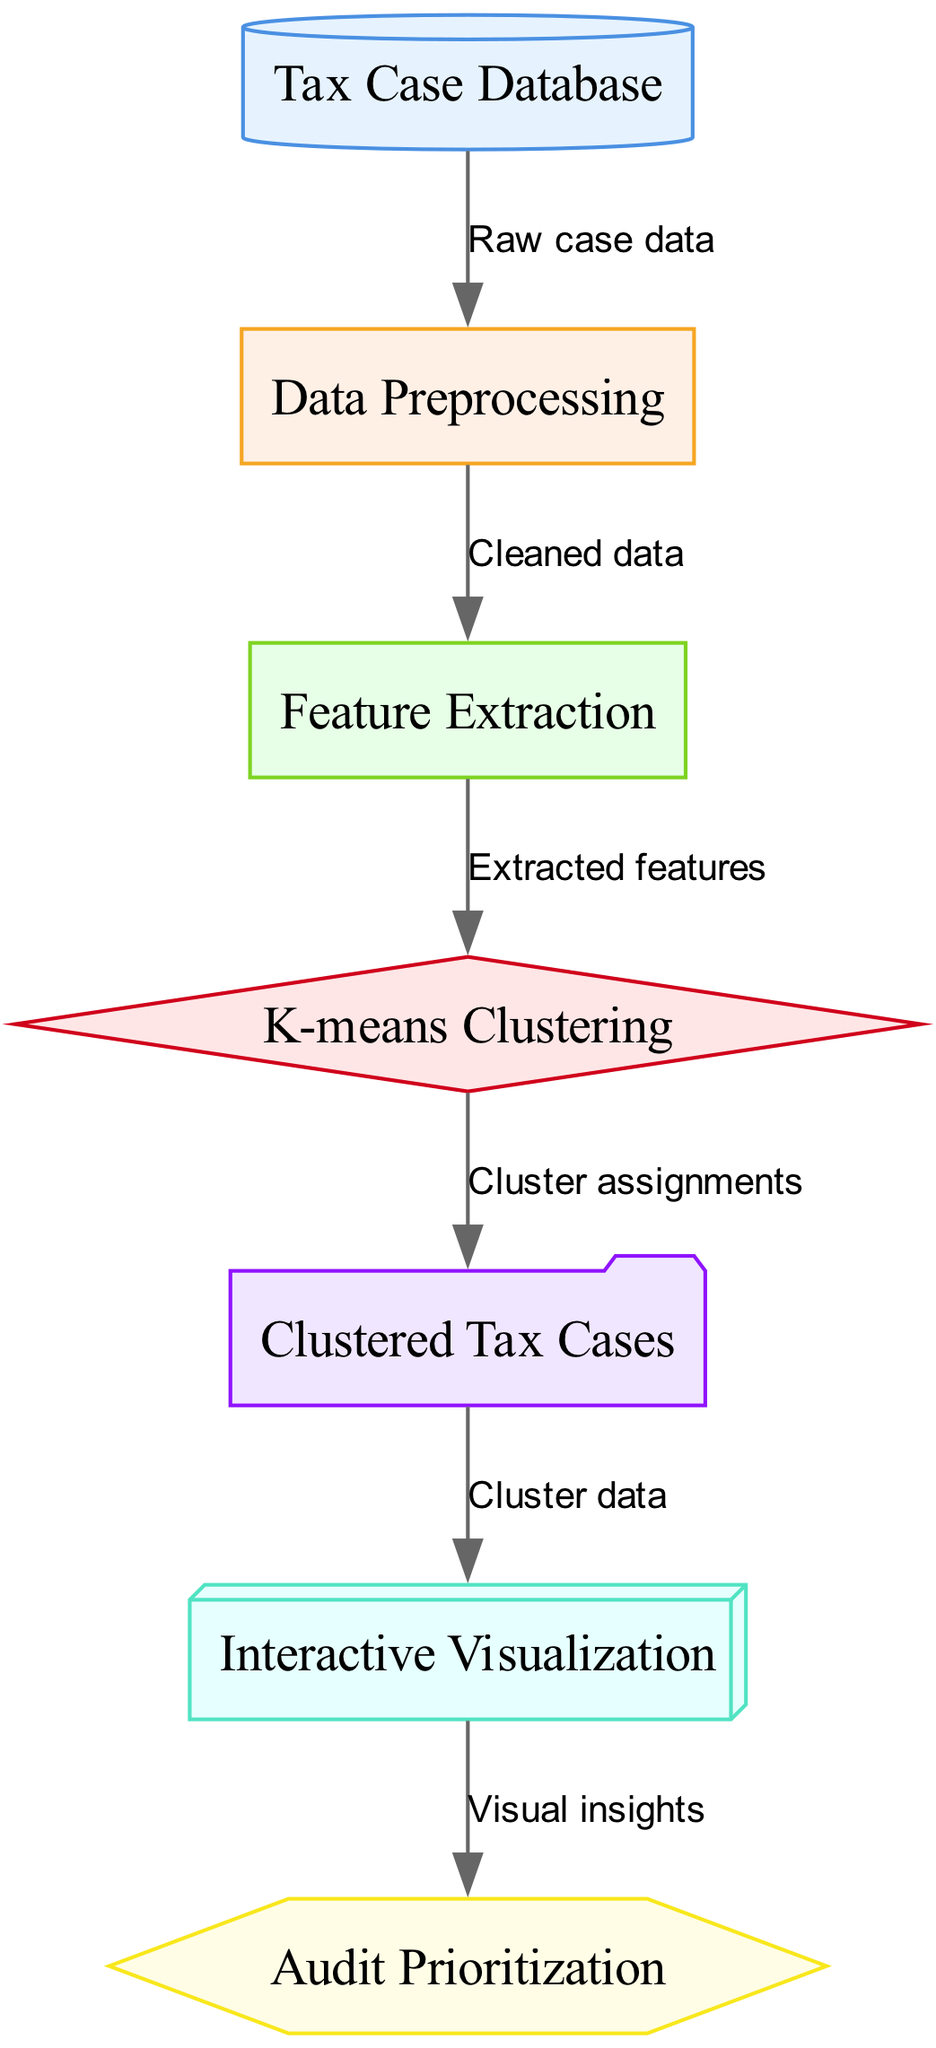What is the first step in the process? The first step is labeled as "Tax Case Database," which indicates that the raw case data is collected and serves as the starting point for the clustering algorithm.
Answer: Tax Case Database How many nodes are in the diagram? By counting the distinct labeled nodes in the diagram, we find there are seven: Tax Case Database, Data Preprocessing, Feature Extraction, K-means Clustering, Clustered Tax Cases, Interactive Visualization, and Audit Prioritization.
Answer: Seven What type of algorithm is used in this diagram? The algorithm used is specified as "K-means Clustering," which indicates the method applied to group similar tax cases based on the extracted features.
Answer: K-means Clustering Which node directly connects the output to visualization? The edge labeled "Cluster data" indicates that the output node "Clustered Tax Cases" connects directly to the "Interactive Visualization" node, showing the flow of information.
Answer: Interactive Visualization What do the visual insights lead to in the end? The visual insights obtained from the "Interactive Visualization" node flow into the final decision-making process, which is labeled as "Audit Prioritization," determining how audits will be prioritized based on the clusters.
Answer: Audit Prioritization In the clustering process, what is used to derive the algorithm? The "Extracted features" derived from the "Feature Extraction" node serve as the input to the "K-means Clustering" algorithm for processing and forming clusters.
Answer: Extracted features What is the relationship between Data Preprocessing and Feature Extraction? The edge labeled "Cleaned data" represents the transition from the "Data Preprocessing" node to the "Feature Extraction" node, indicating that data is cleaned before extracting features.
Answer: Cleaned data What is the function of the Interactive Visualization node? This node provides a means to visualize the clustered tax cases, aiding in understanding the results of the clustering process for better decision making.
Answer: Visualize clustered cases 